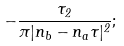Convert formula to latex. <formula><loc_0><loc_0><loc_500><loc_500>- \frac { \tau _ { 2 } } { \pi | n _ { b } - n _ { a } \tau | ^ { 2 } } ;</formula> 